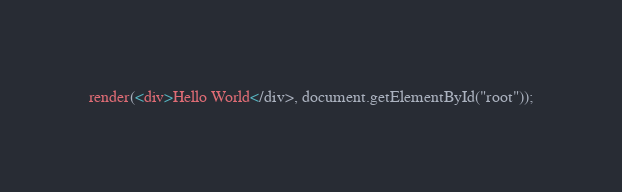<code> <loc_0><loc_0><loc_500><loc_500><_JavaScript_>render(<div>Hello World</div>, document.getElementById("root"));
</code> 